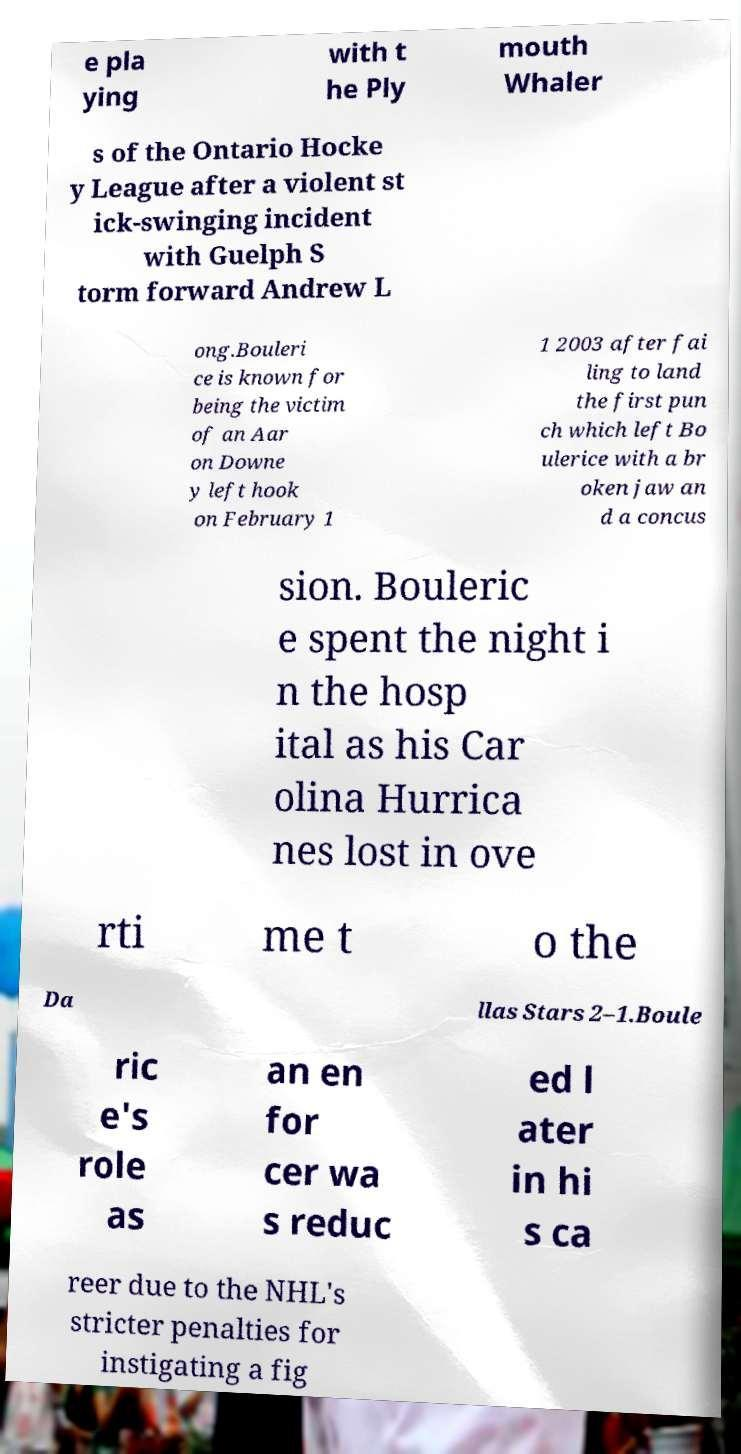Can you read and provide the text displayed in the image?This photo seems to have some interesting text. Can you extract and type it out for me? e pla ying with t he Ply mouth Whaler s of the Ontario Hocke y League after a violent st ick-swinging incident with Guelph S torm forward Andrew L ong.Bouleri ce is known for being the victim of an Aar on Downe y left hook on February 1 1 2003 after fai ling to land the first pun ch which left Bo ulerice with a br oken jaw an d a concus sion. Bouleric e spent the night i n the hosp ital as his Car olina Hurrica nes lost in ove rti me t o the Da llas Stars 2–1.Boule ric e's role as an en for cer wa s reduc ed l ater in hi s ca reer due to the NHL's stricter penalties for instigating a fig 